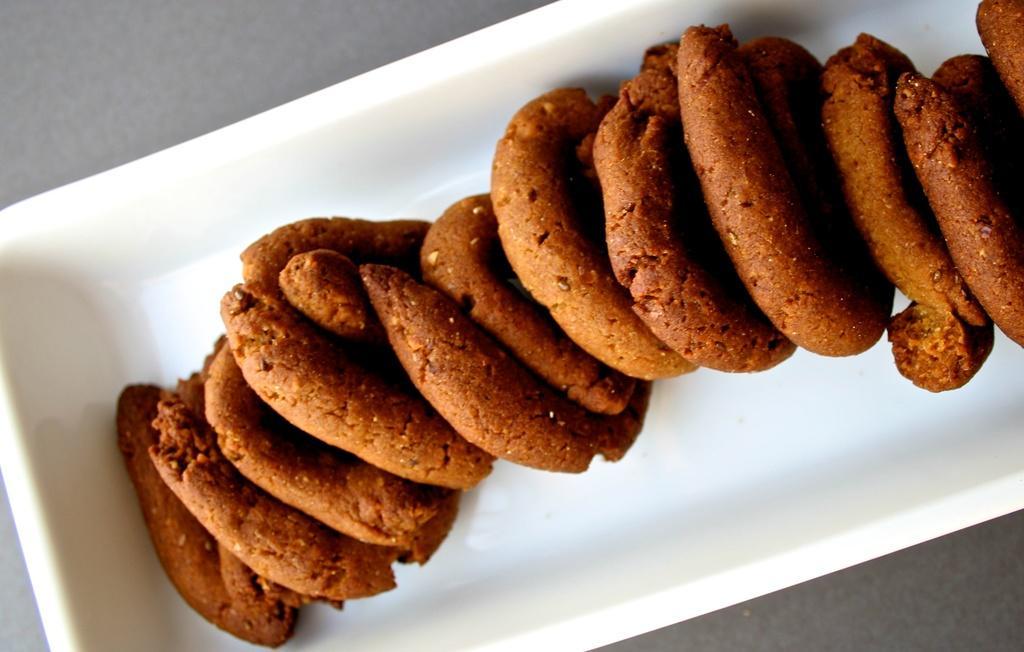In one or two sentences, can you explain what this image depicts? Here I can see few cookies in a white color box. This box is placed on a table. The cookies are in brown color. 